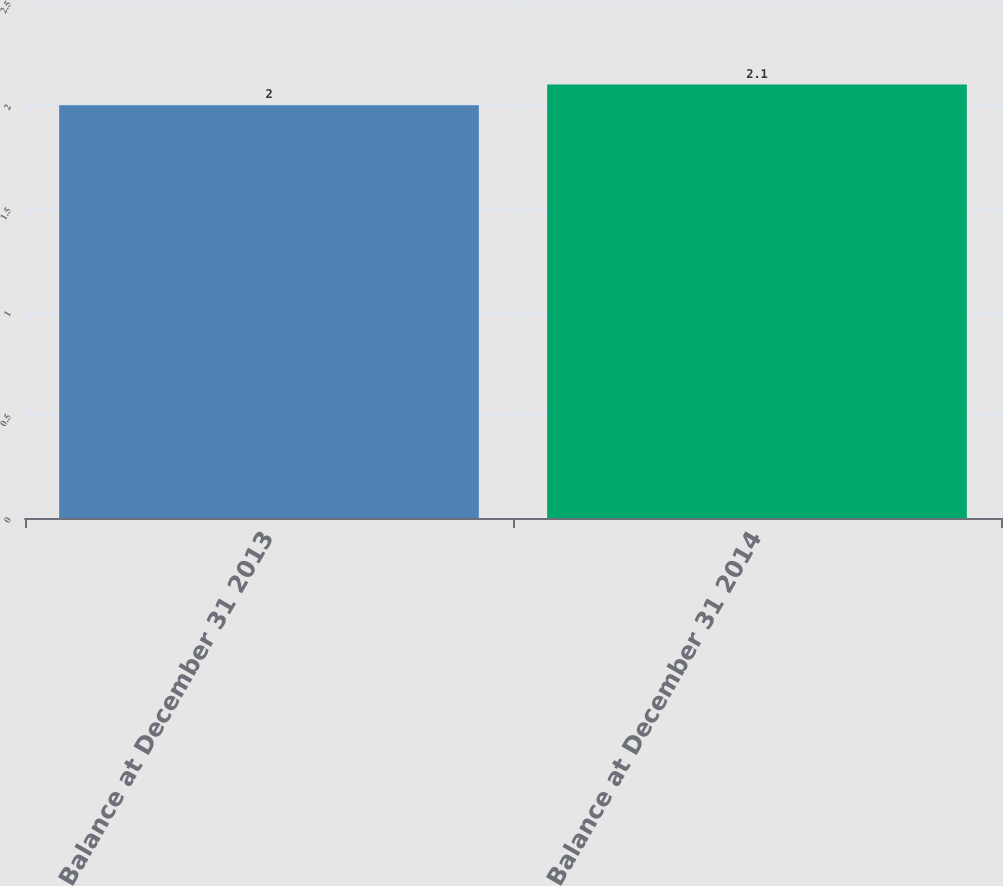<chart> <loc_0><loc_0><loc_500><loc_500><bar_chart><fcel>Balance at December 31 2013<fcel>Balance at December 31 2014<nl><fcel>2<fcel>2.1<nl></chart> 